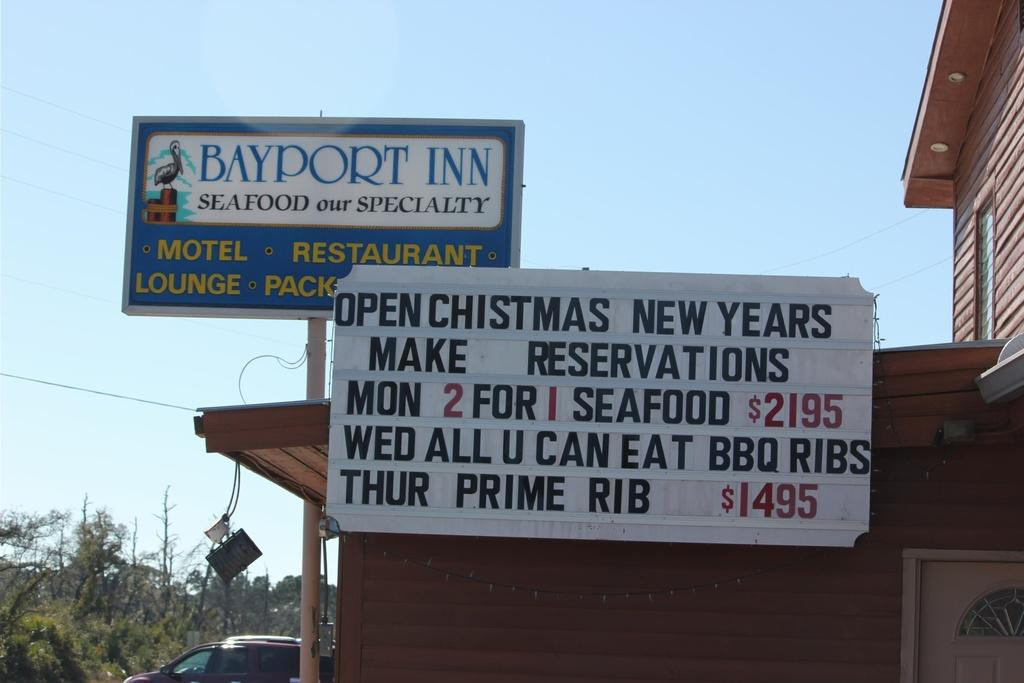<image>
Describe the image concisely. A sign advertises a location as the Bayport Inn motel and restaurant. 